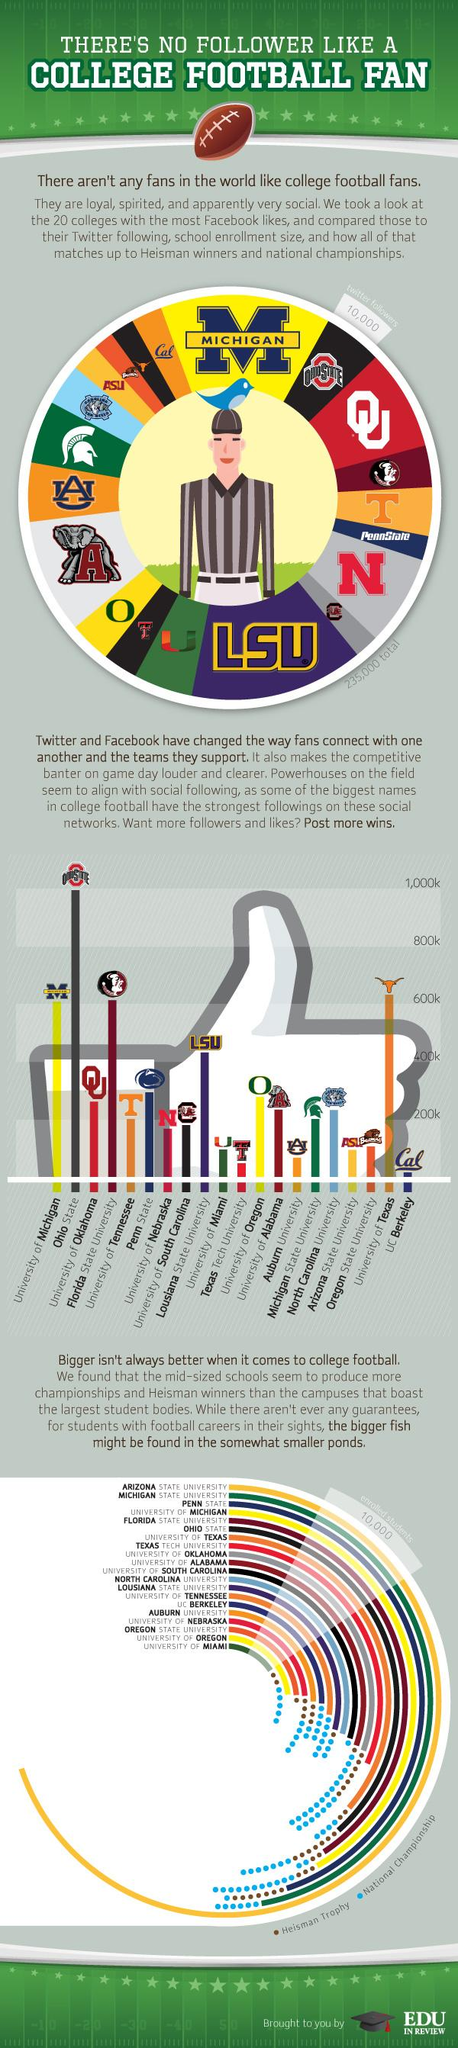Draw attention to some important aspects in this diagram. The University of Miami has won a total of five national championships. Michigan State University has the second largest student body among all universities. The largest student body does not have any Heisman trophies. The color used to represent National championships in a bar plot is blue. The University of Oregon has the second smallest student body among all universities. 